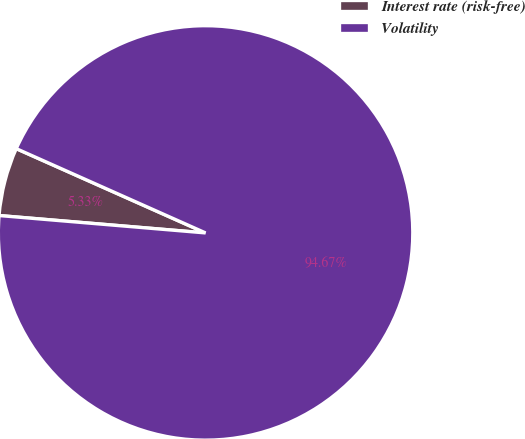Convert chart to OTSL. <chart><loc_0><loc_0><loc_500><loc_500><pie_chart><fcel>Interest rate (risk-free)<fcel>Volatility<nl><fcel>5.33%<fcel>94.67%<nl></chart> 